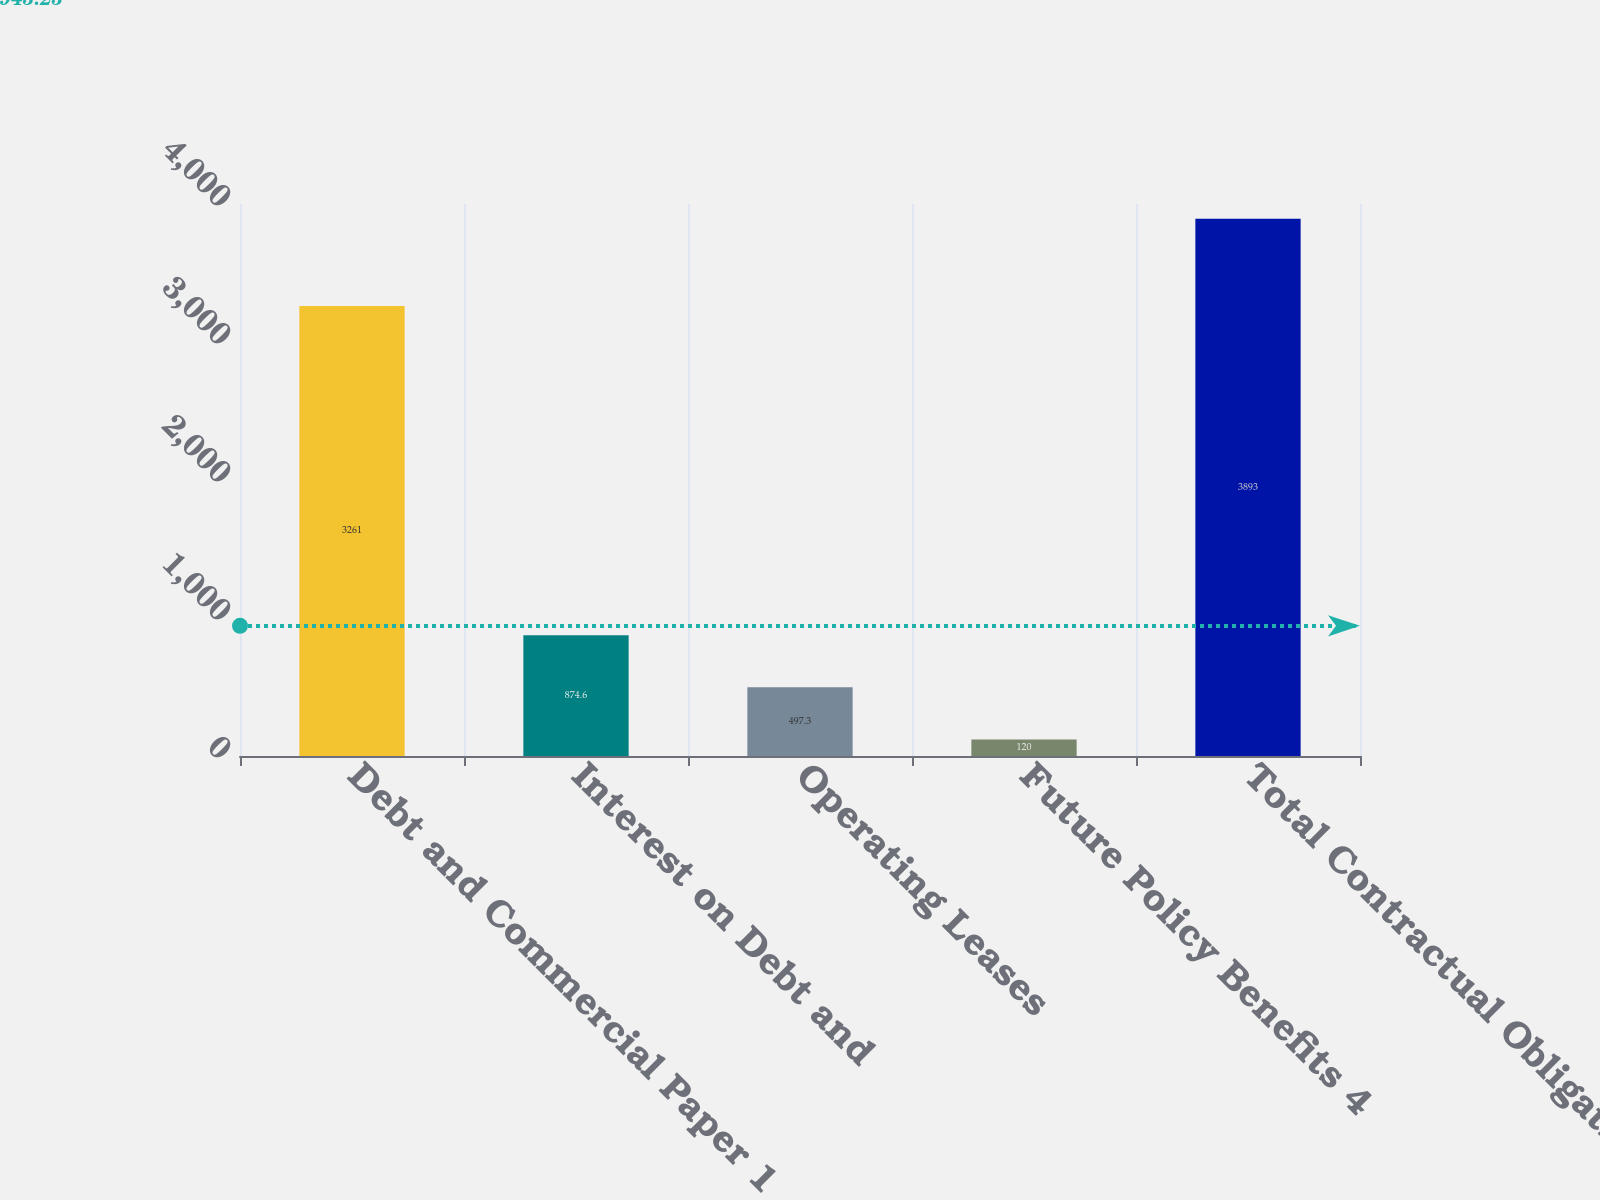Convert chart. <chart><loc_0><loc_0><loc_500><loc_500><bar_chart><fcel>Debt and Commercial Paper 1<fcel>Interest on Debt and<fcel>Operating Leases<fcel>Future Policy Benefits 4<fcel>Total Contractual Obligations<nl><fcel>3261<fcel>874.6<fcel>497.3<fcel>120<fcel>3893<nl></chart> 